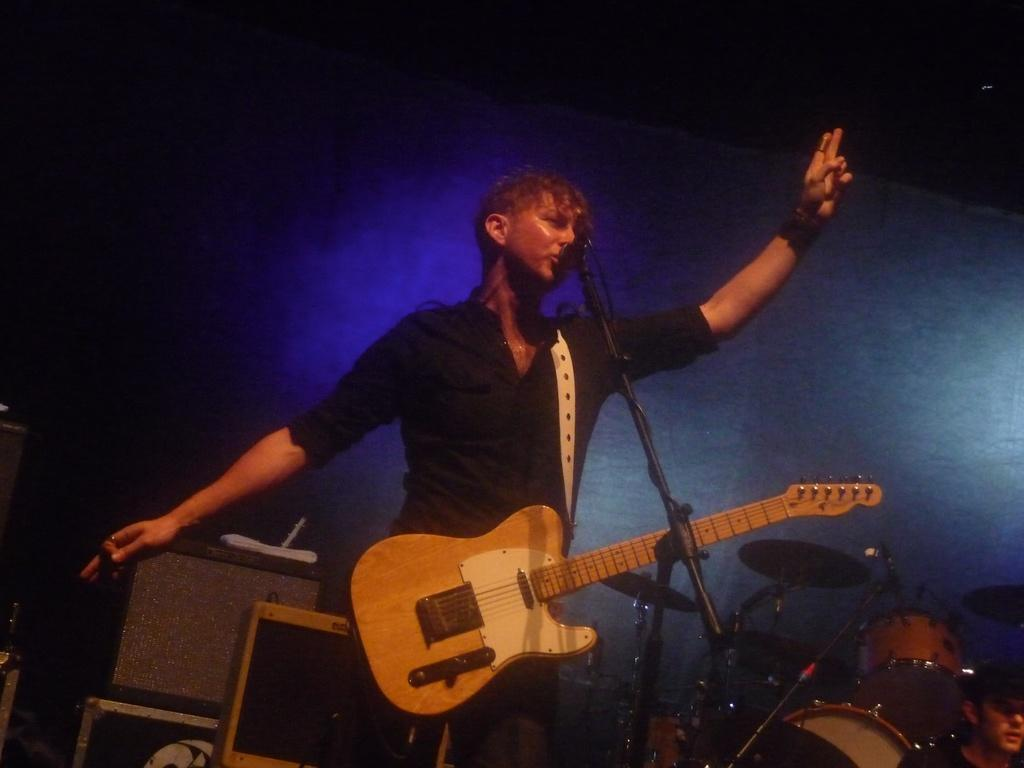What is the main subject of the image? There is a person in the image. What is the person wearing? The person is wearing a black color shirt. What activity is the person engaged in? The person is playing a guitar. What object is in front of the person? There is a microphone in front of the person. What color is the sheet in the background? There is a black color sheet in the background. Can you see any cherries on the floor in the image? There are no cherries present in the image, and the floor is not visible. How many people are trying to join the person playing the guitar in the image? There is no indication of any other people trying to join the person playing the guitar in the image. 